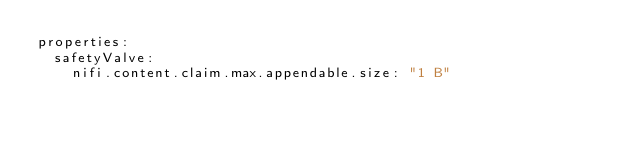<code> <loc_0><loc_0><loc_500><loc_500><_YAML_>properties:
  safetyValve:
    nifi.content.claim.max.appendable.size: "1 B"
</code> 